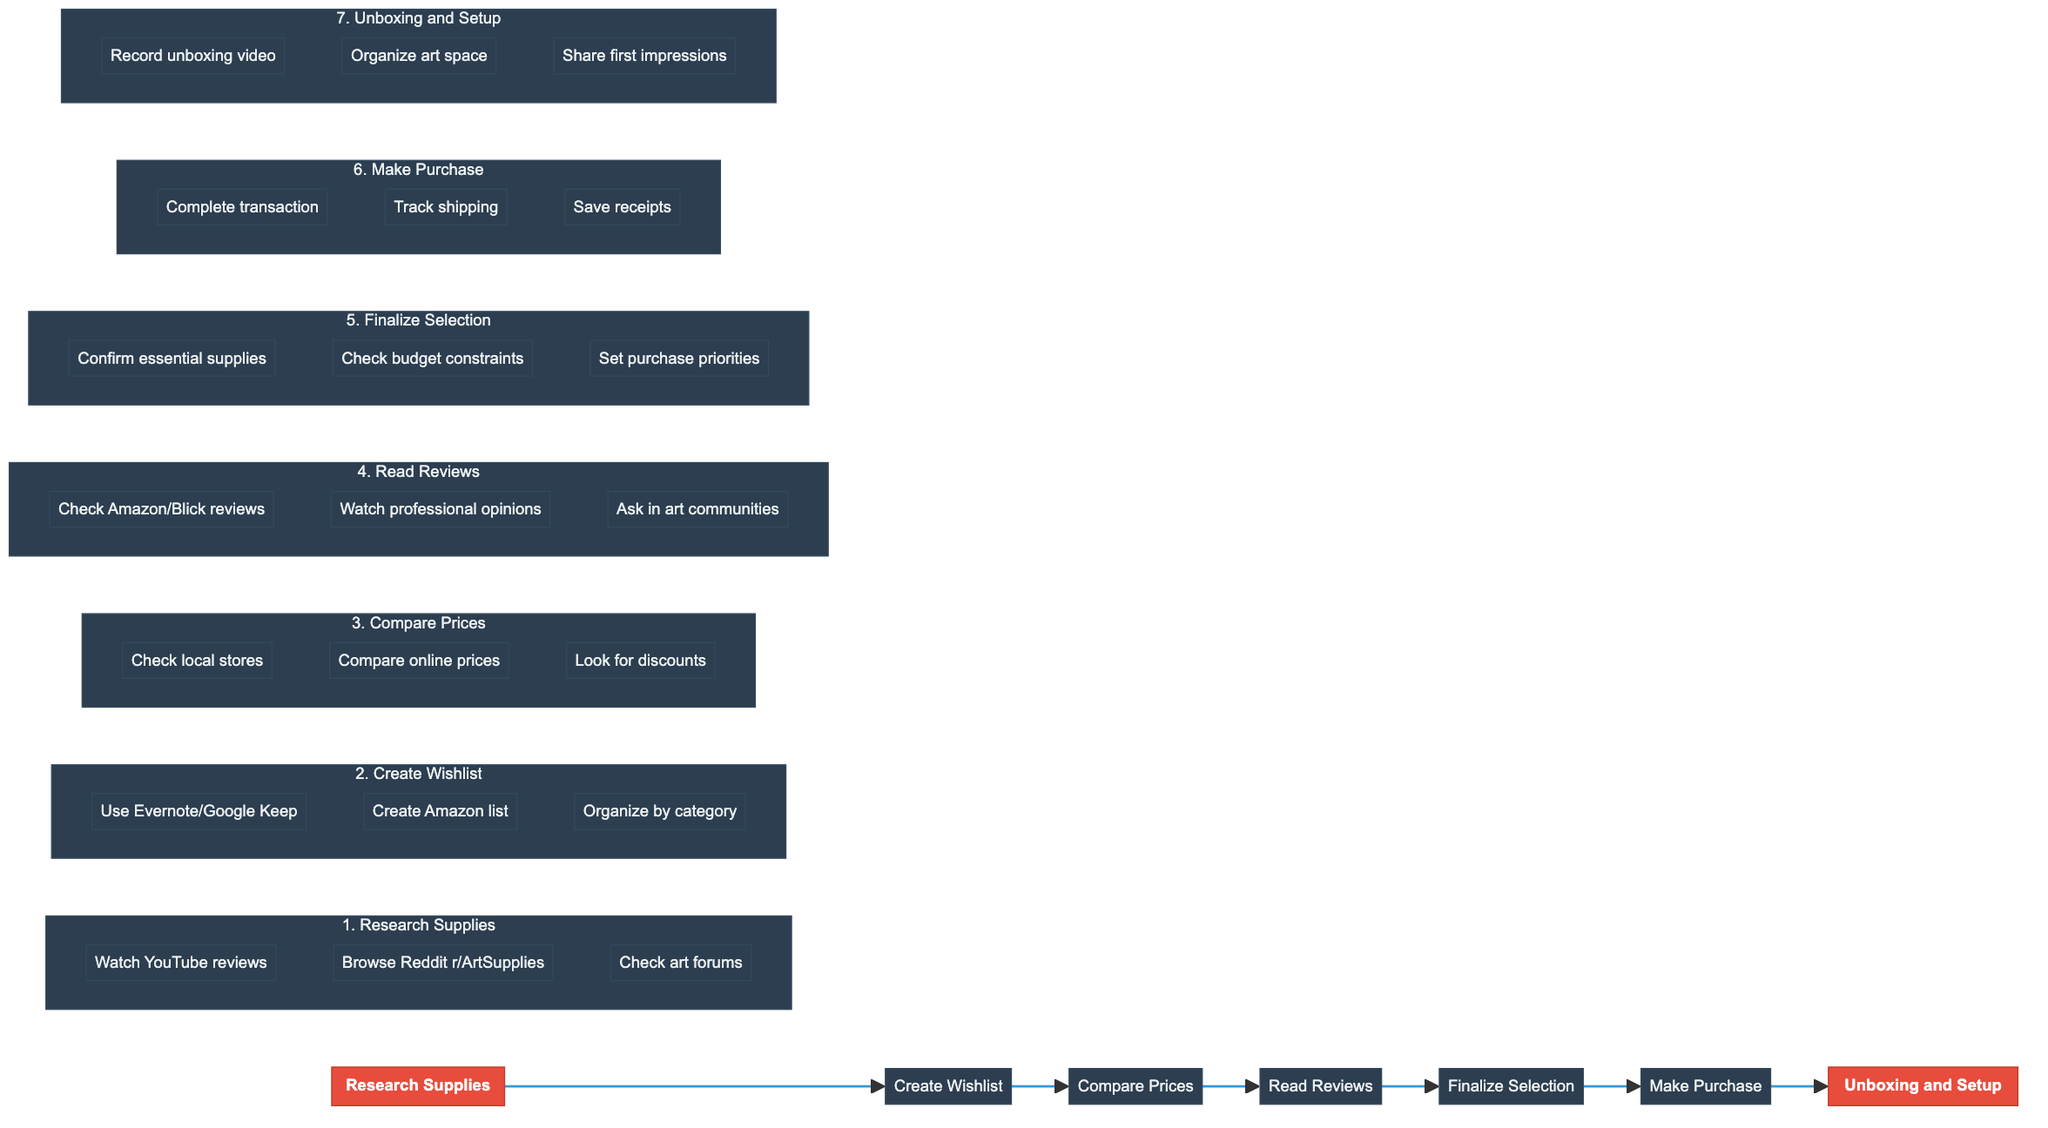What is the first stage of the process? The first stage in the flowchart is labeled as "Research Supplies," which indicates the starting point for the procurement process.
Answer: Research Supplies How many main stages are there in total? The flowchart has a total of seven main stages, indicated by each distinct node connected sequentially.
Answer: 7 What follows the "Compare Prices" stage? Looking at the flowchart, the node that directly follows the "Compare Prices" stage is "Read Reviews," showing the progression from one step to the next.
Answer: Read Reviews Which tools are suggested for creating a wishlist? The diagram lists "Evernote" and "Google Keep" as tools for compiling a wishlist, indicating their importance in the organization of desired supplies.
Answer: Evernote or Google Keep What is one task performed during the "Unboxing and Setup"? In the final stage, one suggested task is "Record unboxing video," highlighting an activity that you might do after receiving the supplies.
Answer: Record unboxing video What is a common theme across the "Read Reviews" and "Compare Prices" stages? Both stages emphasize ensuring quality and value – "Read Reviews" focuses on quality assurance while "Compare Prices" deals with finding the best deal, showcasing a parallel emphasis on informed decision-making.
Answer: Quality and Value What is the last task before making a purchase? Before making a purchase, the final task is to "Set purchase priorities," indicating a need to determine what supplies to buy first based on necessity or budget.
Answer: Set purchase priorities Which sub-stage involves using Amazon as a resource? The sub-stage "Create Amazon list" within the "Create Wishlist" stage points to Amazon as a resource for organizing desired supplies.
Answer: Create Amazon list 